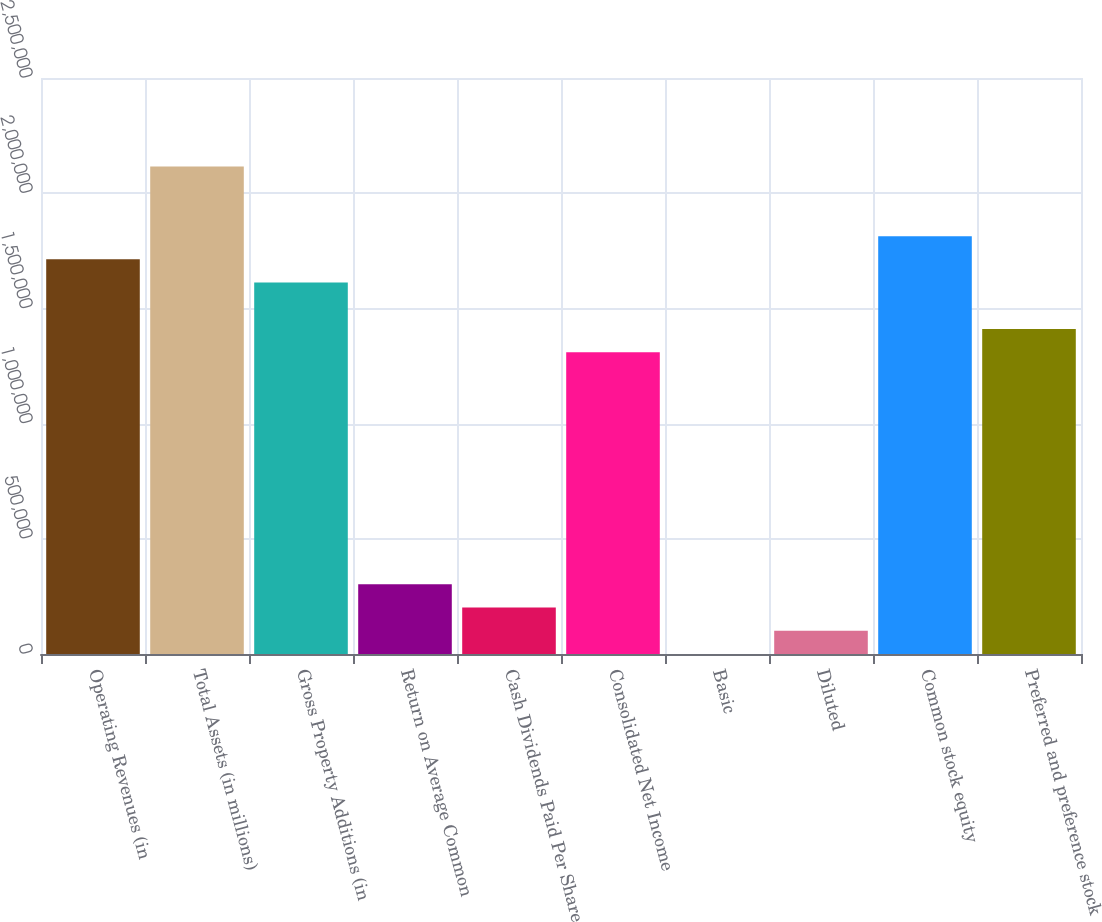Convert chart to OTSL. <chart><loc_0><loc_0><loc_500><loc_500><bar_chart><fcel>Operating Revenues (in<fcel>Total Assets (in millions)<fcel>Gross Property Additions (in<fcel>Return on Average Common<fcel>Cash Dividends Paid Per Share<fcel>Consolidated Net Income<fcel>Basic<fcel>Diluted<fcel>Common stock equity<fcel>Preferred and preference stock<nl><fcel>1.71292e+06<fcel>2.11597e+06<fcel>1.61216e+06<fcel>302282<fcel>201521<fcel>1.30988e+06<fcel>0.84<fcel>100761<fcel>1.81368e+06<fcel>1.41064e+06<nl></chart> 